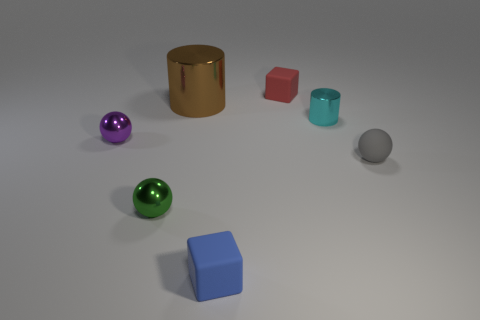Subtract all gray matte balls. How many balls are left? 2 Add 3 tiny blue objects. How many objects exist? 10 Subtract all cyan cylinders. How many cylinders are left? 1 Subtract all red balls. Subtract all purple cubes. How many balls are left? 3 Subtract all green metal cylinders. Subtract all purple balls. How many objects are left? 6 Add 2 blue blocks. How many blue blocks are left? 3 Add 5 large cylinders. How many large cylinders exist? 6 Subtract 0 blue cylinders. How many objects are left? 7 Subtract all balls. How many objects are left? 4 